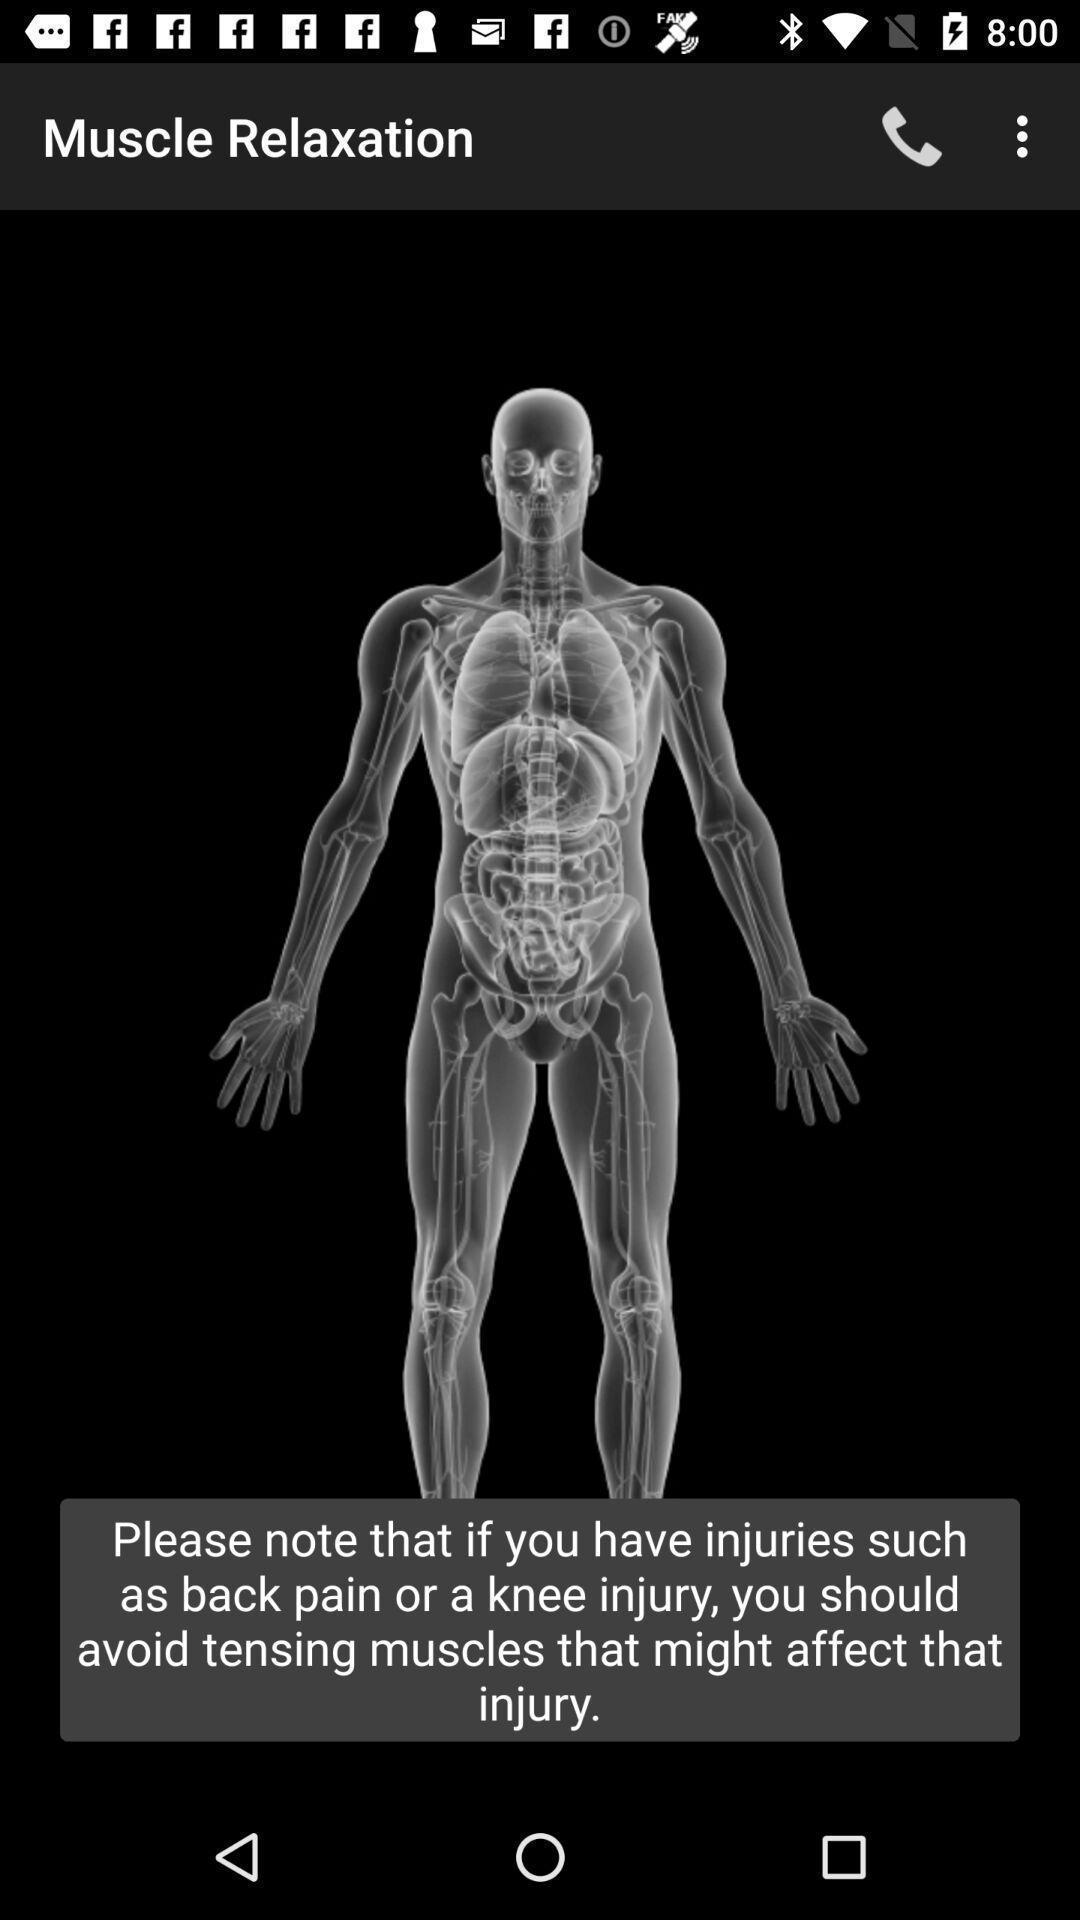Provide a textual representation of this image. Screen shows muscle image. 